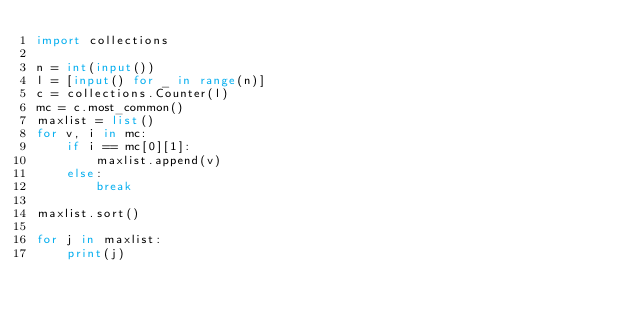<code> <loc_0><loc_0><loc_500><loc_500><_Python_>import collections

n = int(input())
l = [input() for _ in range(n)] 
c = collections.Counter(l)
mc = c.most_common()
maxlist = list()
for v, i in mc:
    if i == mc[0][1]:
        maxlist.append(v)
    else:
        break

maxlist.sort()

for j in maxlist:
    print(j)</code> 